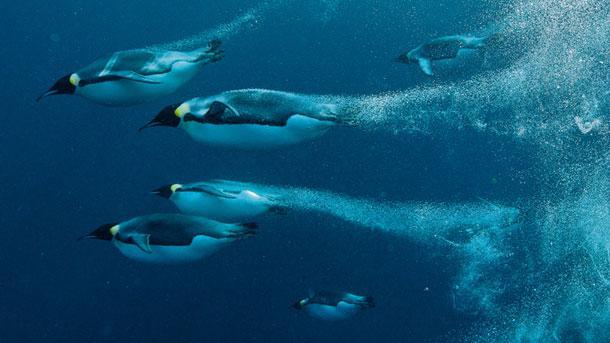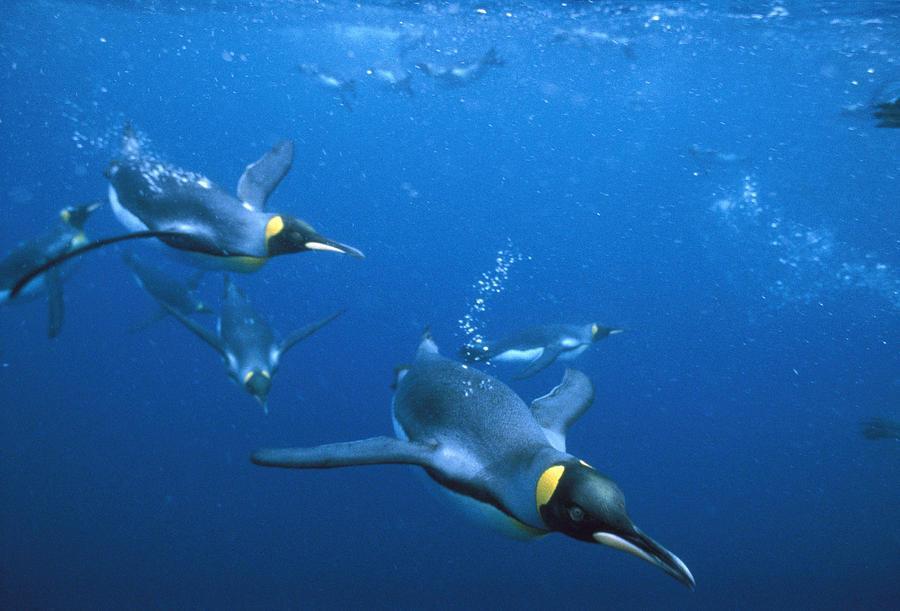The first image is the image on the left, the second image is the image on the right. Assess this claim about the two images: "A single penguin is swimming to the left in one of the images.". Correct or not? Answer yes or no. No. The first image is the image on the left, the second image is the image on the right. Considering the images on both sides, is "An image shows exactly one penguin, which is swimming leftward in front of rocky structures." valid? Answer yes or no. No. 